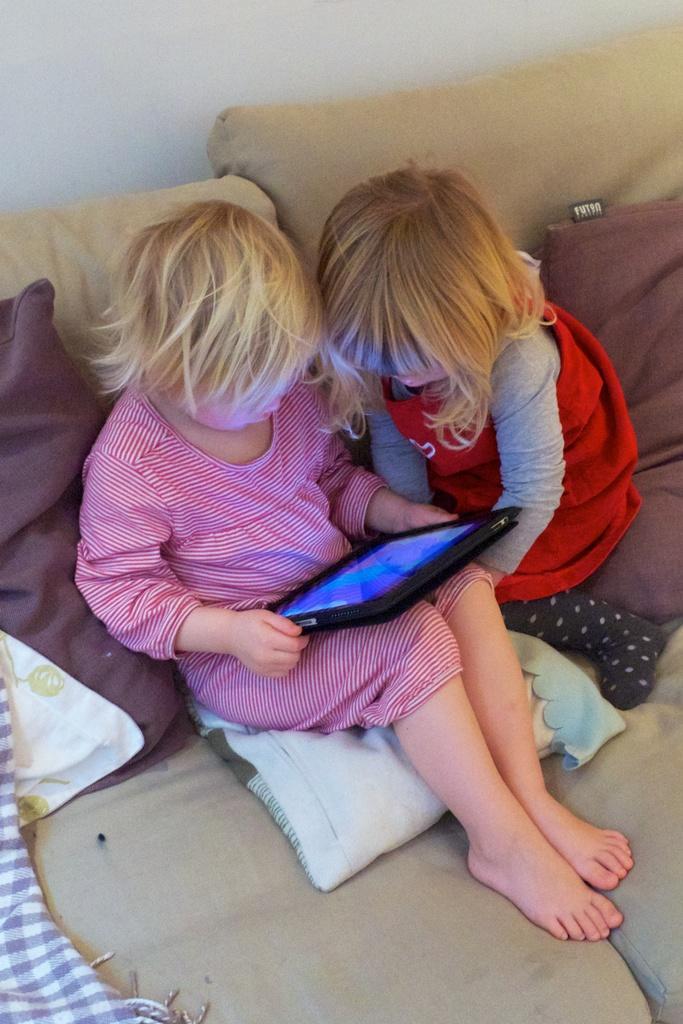In one or two sentences, can you explain what this image depicts? In this image I can see two people with different color dresses. I can see one person is holding the iPad. To the side of these people I can see the pillows. In the background I can see the wall. 